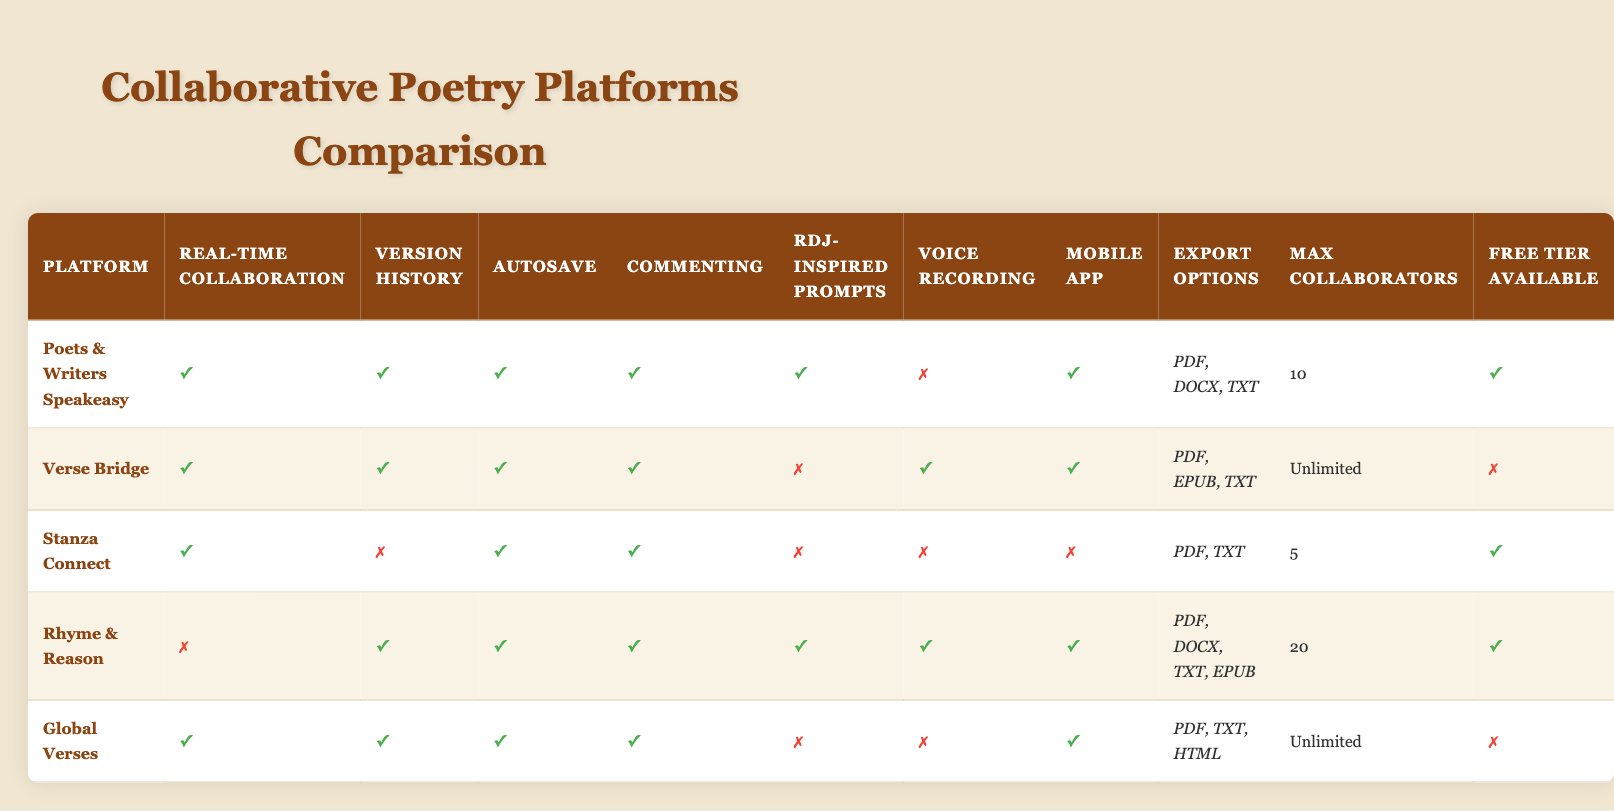What platforms support real-time collaboration? Looking at the table, I list the platforms that have "✓" under the "Real-time Collaboration" column: Poets & Writers Speakeasy, Verse Bridge, Stanza Connect, Global Verses.
Answer: Poets & Writers Speakeasy, Verse Bridge, Stanza Connect, Global Verses Which platform has the most maximum collaborators? By examining the "Max Collaborators" column, I observe that Verse Bridge and Global Verses have "Unlimited," while the others have specific numbers. Therefore, the platforms with the most maximum collaborators are Verse Bridge and Global Verses.
Answer: Verse Bridge and Global Verses Is there a platform that offers RDJ-inspired prompts and voice recording? Looking through the "RDJ-inspired Prompts" and "Voice Recording" columns, I find Rhyme & Reason has "✓" for both features, thus confirming it offers both prompts and voice recording.
Answer: Yes, Rhyme & Reason What is the average number of maximum collaborators across all platforms? I note the maximum collaborators for each platform: 10 (Poets & Writers), Unlimited (assumed as a high value, but not specific), 5 (Stanza Connect), 20 (Rhyme & Reason), Unlimited (Global Verses). Counting valid numbers: 10, 5, and 20 gives 35. Ignoring unlimited, we divide the sum by 3 valid values: 35/3 ≈ 11.67.
Answer: Approximately 11.67 Which platform has version history but does not support real-time collaboration? Checking the "Version History" and "Real-time Collaboration" columns, I see that Rhyme & Reason has "✓" under Version History but "✗" under Real-time Collaboration. It's the only platform that fits this criterion.
Answer: Rhyme & Reason Do all platforms offer a free tier? By inspecting the "Free Tier Available" column, I see Poets & Writers Speakeasy, Stanza Connect, Rhyme & Reason offer a free tier, but Verse Bridge and Global Verses do not. Therefore, not all platforms offer a free tier.
Answer: No Which platform allows for the most export options? Upon reviewing the "Export Options" column, I see that Rhyme & Reason allows four export formats: PDF, DOCX, TXT, EPUB, making it the platform with the most export options.
Answer: Rhyme & Reason Are there any platforms that have both mobile apps and voice recording features? Checking both the "Mobile App" and "Voice Recording" columns, I find Verse Bridge and Rhyme & Reason both have "✓" under these features.
Answer: Yes, Verse Bridge and Rhyme & Reason What is the total number of platforms that support commenting features? I check the "Commenting" column for each platform and count how many have "✓." Poets & Writers Speakeasy, Verse Bridge, Stanza Connect, Rhyme & Reason, and Global Verses all have commenting features enabled, totaling five platforms.
Answer: 5 